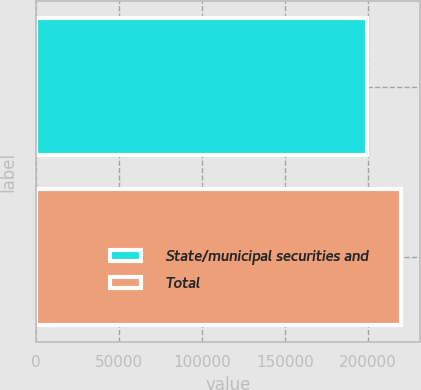Convert chart. <chart><loc_0><loc_0><loc_500><loc_500><bar_chart><fcel>State/municipal securities and<fcel>Total<nl><fcel>199725<fcel>220335<nl></chart> 